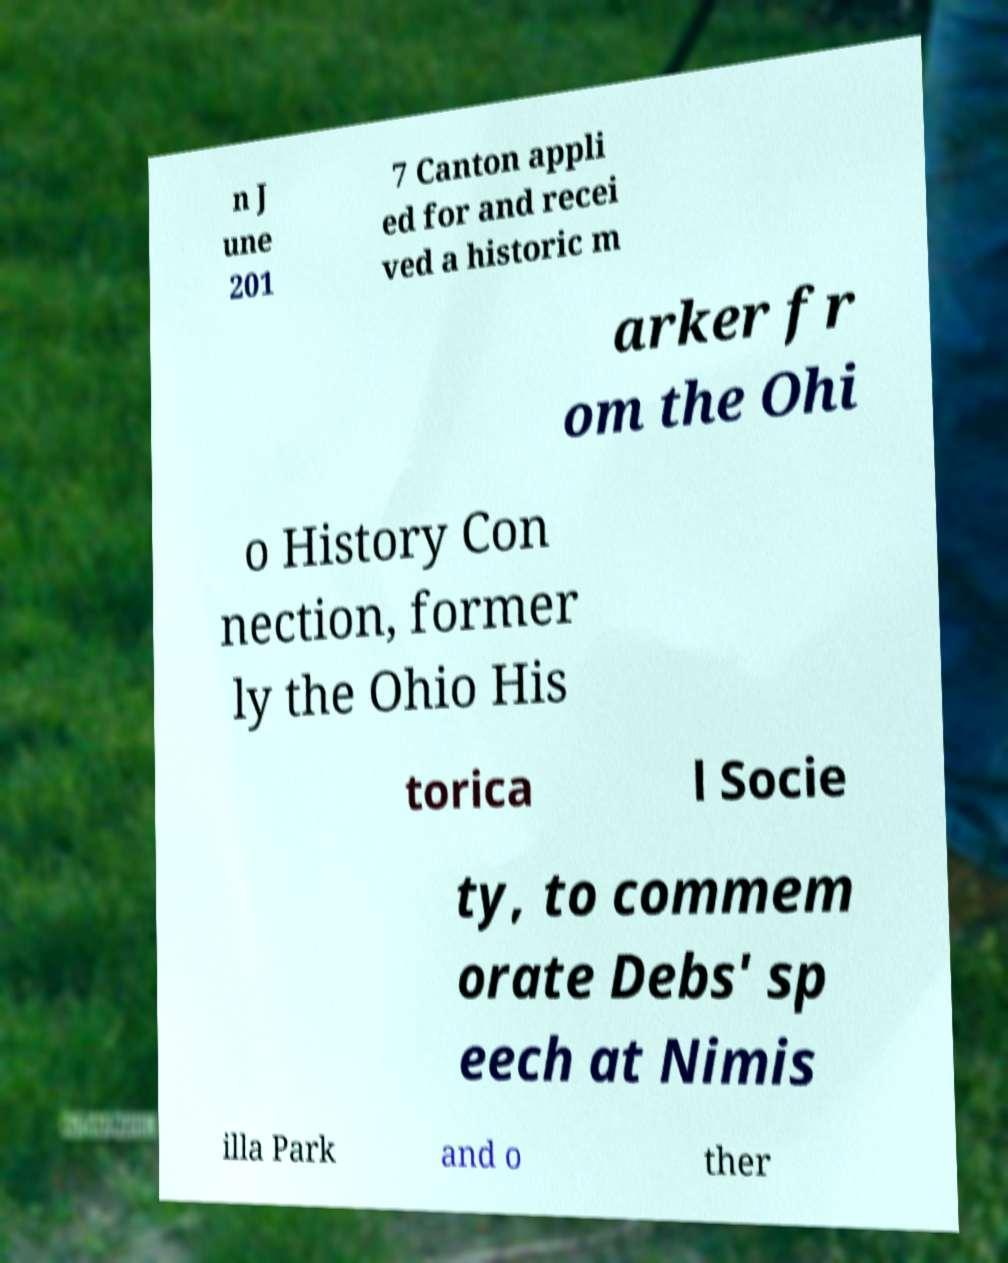Could you extract and type out the text from this image? n J une 201 7 Canton appli ed for and recei ved a historic m arker fr om the Ohi o History Con nection, former ly the Ohio His torica l Socie ty, to commem orate Debs' sp eech at Nimis illa Park and o ther 